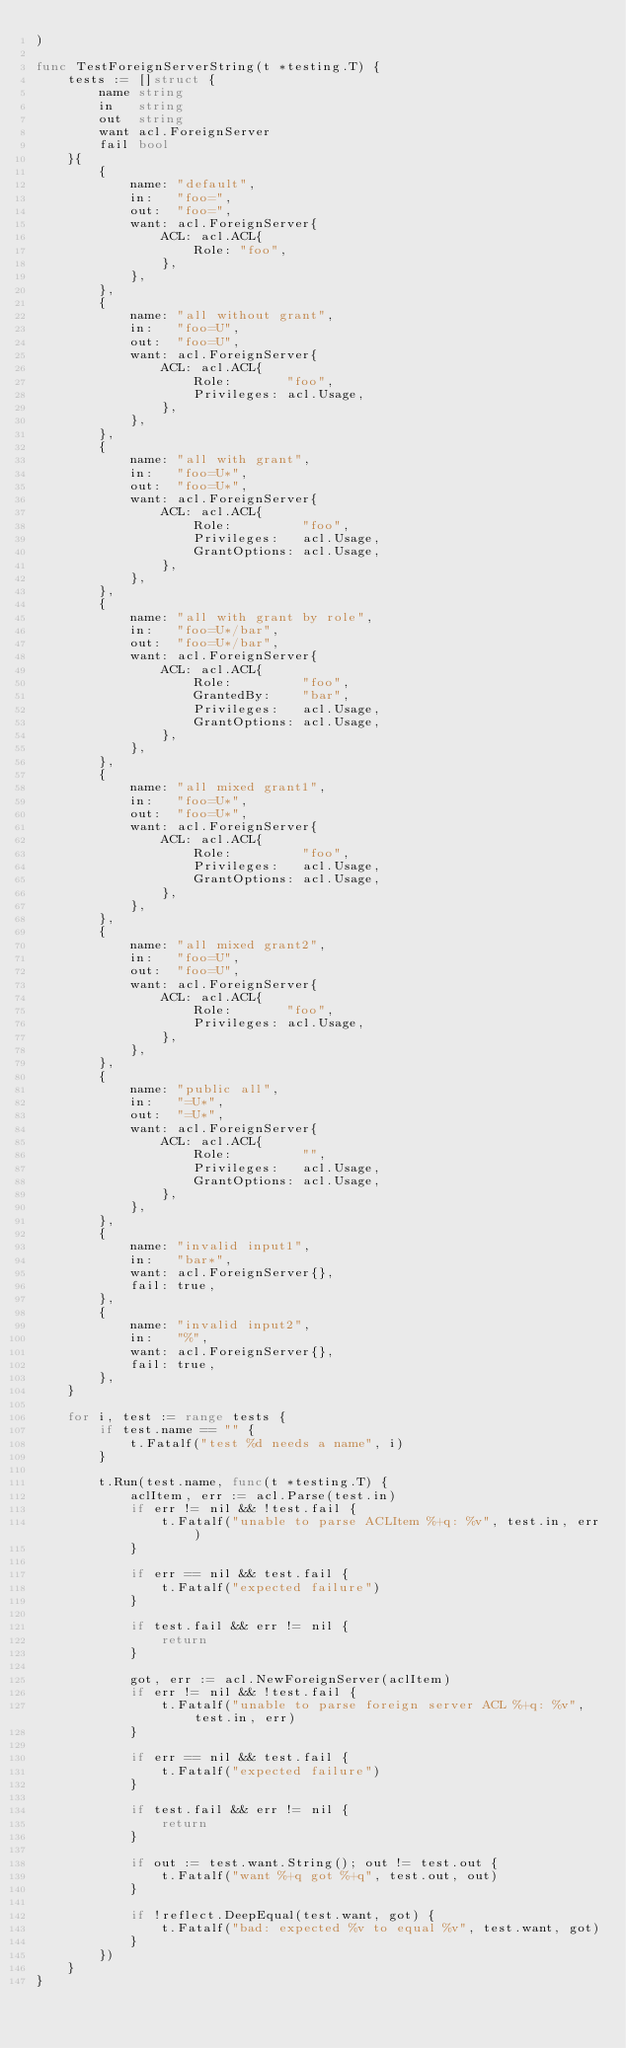Convert code to text. <code><loc_0><loc_0><loc_500><loc_500><_Go_>)

func TestForeignServerString(t *testing.T) {
	tests := []struct {
		name string
		in   string
		out  string
		want acl.ForeignServer
		fail bool
	}{
		{
			name: "default",
			in:   "foo=",
			out:  "foo=",
			want: acl.ForeignServer{
				ACL: acl.ACL{
					Role: "foo",
				},
			},
		},
		{
			name: "all without grant",
			in:   "foo=U",
			out:  "foo=U",
			want: acl.ForeignServer{
				ACL: acl.ACL{
					Role:       "foo",
					Privileges: acl.Usage,
				},
			},
		},
		{
			name: "all with grant",
			in:   "foo=U*",
			out:  "foo=U*",
			want: acl.ForeignServer{
				ACL: acl.ACL{
					Role:         "foo",
					Privileges:   acl.Usage,
					GrantOptions: acl.Usage,
				},
			},
		},
		{
			name: "all with grant by role",
			in:   "foo=U*/bar",
			out:  "foo=U*/bar",
			want: acl.ForeignServer{
				ACL: acl.ACL{
					Role:         "foo",
					GrantedBy:    "bar",
					Privileges:   acl.Usage,
					GrantOptions: acl.Usage,
				},
			},
		},
		{
			name: "all mixed grant1",
			in:   "foo=U*",
			out:  "foo=U*",
			want: acl.ForeignServer{
				ACL: acl.ACL{
					Role:         "foo",
					Privileges:   acl.Usage,
					GrantOptions: acl.Usage,
				},
			},
		},
		{
			name: "all mixed grant2",
			in:   "foo=U",
			out:  "foo=U",
			want: acl.ForeignServer{
				ACL: acl.ACL{
					Role:       "foo",
					Privileges: acl.Usage,
				},
			},
		},
		{
			name: "public all",
			in:   "=U*",
			out:  "=U*",
			want: acl.ForeignServer{
				ACL: acl.ACL{
					Role:         "",
					Privileges:   acl.Usage,
					GrantOptions: acl.Usage,
				},
			},
		},
		{
			name: "invalid input1",
			in:   "bar*",
			want: acl.ForeignServer{},
			fail: true,
		},
		{
			name: "invalid input2",
			in:   "%",
			want: acl.ForeignServer{},
			fail: true,
		},
	}

	for i, test := range tests {
		if test.name == "" {
			t.Fatalf("test %d needs a name", i)
		}

		t.Run(test.name, func(t *testing.T) {
			aclItem, err := acl.Parse(test.in)
			if err != nil && !test.fail {
				t.Fatalf("unable to parse ACLItem %+q: %v", test.in, err)
			}

			if err == nil && test.fail {
				t.Fatalf("expected failure")
			}

			if test.fail && err != nil {
				return
			}

			got, err := acl.NewForeignServer(aclItem)
			if err != nil && !test.fail {
				t.Fatalf("unable to parse foreign server ACL %+q: %v", test.in, err)
			}

			if err == nil && test.fail {
				t.Fatalf("expected failure")
			}

			if test.fail && err != nil {
				return
			}

			if out := test.want.String(); out != test.out {
				t.Fatalf("want %+q got %+q", test.out, out)
			}

			if !reflect.DeepEqual(test.want, got) {
				t.Fatalf("bad: expected %v to equal %v", test.want, got)
			}
		})
	}
}
</code> 